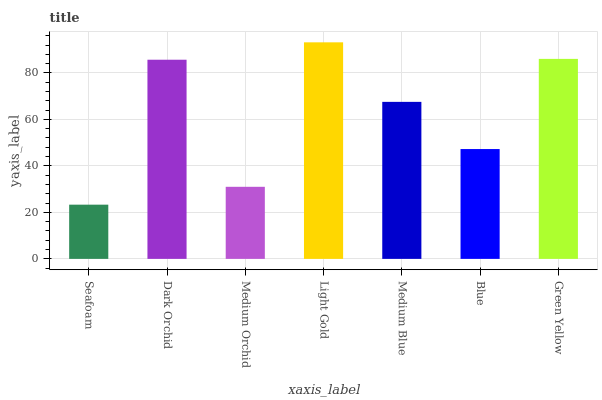Is Dark Orchid the minimum?
Answer yes or no. No. Is Dark Orchid the maximum?
Answer yes or no. No. Is Dark Orchid greater than Seafoam?
Answer yes or no. Yes. Is Seafoam less than Dark Orchid?
Answer yes or no. Yes. Is Seafoam greater than Dark Orchid?
Answer yes or no. No. Is Dark Orchid less than Seafoam?
Answer yes or no. No. Is Medium Blue the high median?
Answer yes or no. Yes. Is Medium Blue the low median?
Answer yes or no. Yes. Is Dark Orchid the high median?
Answer yes or no. No. Is Seafoam the low median?
Answer yes or no. No. 